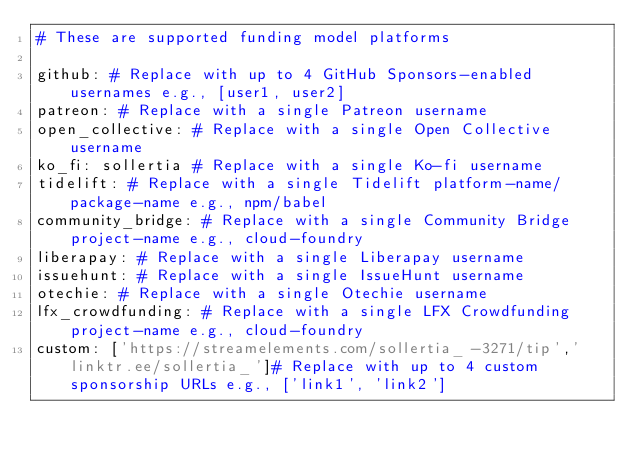<code> <loc_0><loc_0><loc_500><loc_500><_YAML_># These are supported funding model platforms

github: # Replace with up to 4 GitHub Sponsors-enabled usernames e.g., [user1, user2]
patreon: # Replace with a single Patreon username
open_collective: # Replace with a single Open Collective username
ko_fi: sollertia # Replace with a single Ko-fi username
tidelift: # Replace with a single Tidelift platform-name/package-name e.g., npm/babel
community_bridge: # Replace with a single Community Bridge project-name e.g., cloud-foundry
liberapay: # Replace with a single Liberapay username
issuehunt: # Replace with a single IssueHunt username
otechie: # Replace with a single Otechie username
lfx_crowdfunding: # Replace with a single LFX Crowdfunding project-name e.g., cloud-foundry
custom: ['https://streamelements.com/sollertia_-3271/tip','linktr.ee/sollertia_']# Replace with up to 4 custom sponsorship URLs e.g., ['link1', 'link2']
</code> 